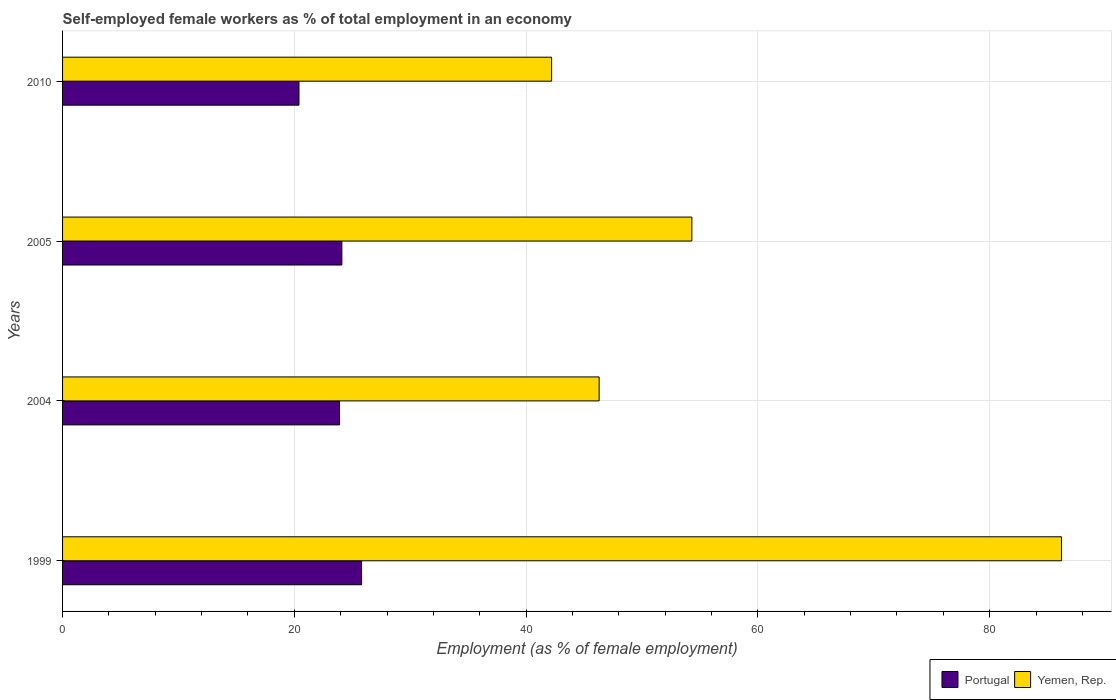How many different coloured bars are there?
Offer a terse response. 2. How many bars are there on the 4th tick from the top?
Your answer should be compact. 2. How many bars are there on the 4th tick from the bottom?
Provide a short and direct response. 2. What is the label of the 3rd group of bars from the top?
Ensure brevity in your answer.  2004. What is the percentage of self-employed female workers in Yemen, Rep. in 1999?
Provide a short and direct response. 86.2. Across all years, what is the maximum percentage of self-employed female workers in Portugal?
Your response must be concise. 25.8. Across all years, what is the minimum percentage of self-employed female workers in Yemen, Rep.?
Offer a terse response. 42.2. In which year was the percentage of self-employed female workers in Yemen, Rep. minimum?
Provide a succinct answer. 2010. What is the total percentage of self-employed female workers in Yemen, Rep. in the graph?
Offer a very short reply. 229. What is the difference between the percentage of self-employed female workers in Yemen, Rep. in 1999 and that in 2005?
Provide a short and direct response. 31.9. What is the difference between the percentage of self-employed female workers in Yemen, Rep. in 2010 and the percentage of self-employed female workers in Portugal in 2005?
Provide a succinct answer. 18.1. What is the average percentage of self-employed female workers in Portugal per year?
Your response must be concise. 23.55. In the year 1999, what is the difference between the percentage of self-employed female workers in Yemen, Rep. and percentage of self-employed female workers in Portugal?
Offer a very short reply. 60.4. What is the ratio of the percentage of self-employed female workers in Yemen, Rep. in 1999 to that in 2004?
Provide a succinct answer. 1.86. What is the difference between the highest and the second highest percentage of self-employed female workers in Portugal?
Ensure brevity in your answer.  1.7. What is the difference between the highest and the lowest percentage of self-employed female workers in Yemen, Rep.?
Make the answer very short. 44. In how many years, is the percentage of self-employed female workers in Portugal greater than the average percentage of self-employed female workers in Portugal taken over all years?
Provide a succinct answer. 3. What does the 2nd bar from the bottom in 2005 represents?
Offer a very short reply. Yemen, Rep. Are the values on the major ticks of X-axis written in scientific E-notation?
Provide a short and direct response. No. What is the title of the graph?
Give a very brief answer. Self-employed female workers as % of total employment in an economy. What is the label or title of the X-axis?
Your response must be concise. Employment (as % of female employment). What is the Employment (as % of female employment) in Portugal in 1999?
Keep it short and to the point. 25.8. What is the Employment (as % of female employment) in Yemen, Rep. in 1999?
Offer a very short reply. 86.2. What is the Employment (as % of female employment) in Portugal in 2004?
Your answer should be very brief. 23.9. What is the Employment (as % of female employment) of Yemen, Rep. in 2004?
Your answer should be very brief. 46.3. What is the Employment (as % of female employment) of Portugal in 2005?
Ensure brevity in your answer.  24.1. What is the Employment (as % of female employment) of Yemen, Rep. in 2005?
Keep it short and to the point. 54.3. What is the Employment (as % of female employment) in Portugal in 2010?
Provide a succinct answer. 20.4. What is the Employment (as % of female employment) in Yemen, Rep. in 2010?
Offer a very short reply. 42.2. Across all years, what is the maximum Employment (as % of female employment) of Portugal?
Make the answer very short. 25.8. Across all years, what is the maximum Employment (as % of female employment) of Yemen, Rep.?
Your answer should be compact. 86.2. Across all years, what is the minimum Employment (as % of female employment) in Portugal?
Provide a succinct answer. 20.4. Across all years, what is the minimum Employment (as % of female employment) of Yemen, Rep.?
Ensure brevity in your answer.  42.2. What is the total Employment (as % of female employment) in Portugal in the graph?
Give a very brief answer. 94.2. What is the total Employment (as % of female employment) in Yemen, Rep. in the graph?
Ensure brevity in your answer.  229. What is the difference between the Employment (as % of female employment) of Portugal in 1999 and that in 2004?
Keep it short and to the point. 1.9. What is the difference between the Employment (as % of female employment) of Yemen, Rep. in 1999 and that in 2004?
Keep it short and to the point. 39.9. What is the difference between the Employment (as % of female employment) in Portugal in 1999 and that in 2005?
Keep it short and to the point. 1.7. What is the difference between the Employment (as % of female employment) of Yemen, Rep. in 1999 and that in 2005?
Ensure brevity in your answer.  31.9. What is the difference between the Employment (as % of female employment) in Portugal in 2004 and that in 2005?
Give a very brief answer. -0.2. What is the difference between the Employment (as % of female employment) of Yemen, Rep. in 2004 and that in 2005?
Ensure brevity in your answer.  -8. What is the difference between the Employment (as % of female employment) in Portugal in 2004 and that in 2010?
Offer a very short reply. 3.5. What is the difference between the Employment (as % of female employment) of Portugal in 2005 and that in 2010?
Ensure brevity in your answer.  3.7. What is the difference between the Employment (as % of female employment) in Yemen, Rep. in 2005 and that in 2010?
Your answer should be very brief. 12.1. What is the difference between the Employment (as % of female employment) of Portugal in 1999 and the Employment (as % of female employment) of Yemen, Rep. in 2004?
Offer a terse response. -20.5. What is the difference between the Employment (as % of female employment) in Portugal in 1999 and the Employment (as % of female employment) in Yemen, Rep. in 2005?
Your answer should be compact. -28.5. What is the difference between the Employment (as % of female employment) of Portugal in 1999 and the Employment (as % of female employment) of Yemen, Rep. in 2010?
Your answer should be very brief. -16.4. What is the difference between the Employment (as % of female employment) of Portugal in 2004 and the Employment (as % of female employment) of Yemen, Rep. in 2005?
Offer a terse response. -30.4. What is the difference between the Employment (as % of female employment) of Portugal in 2004 and the Employment (as % of female employment) of Yemen, Rep. in 2010?
Your response must be concise. -18.3. What is the difference between the Employment (as % of female employment) in Portugal in 2005 and the Employment (as % of female employment) in Yemen, Rep. in 2010?
Provide a short and direct response. -18.1. What is the average Employment (as % of female employment) of Portugal per year?
Make the answer very short. 23.55. What is the average Employment (as % of female employment) in Yemen, Rep. per year?
Ensure brevity in your answer.  57.25. In the year 1999, what is the difference between the Employment (as % of female employment) in Portugal and Employment (as % of female employment) in Yemen, Rep.?
Give a very brief answer. -60.4. In the year 2004, what is the difference between the Employment (as % of female employment) of Portugal and Employment (as % of female employment) of Yemen, Rep.?
Provide a short and direct response. -22.4. In the year 2005, what is the difference between the Employment (as % of female employment) in Portugal and Employment (as % of female employment) in Yemen, Rep.?
Keep it short and to the point. -30.2. In the year 2010, what is the difference between the Employment (as % of female employment) in Portugal and Employment (as % of female employment) in Yemen, Rep.?
Give a very brief answer. -21.8. What is the ratio of the Employment (as % of female employment) of Portugal in 1999 to that in 2004?
Give a very brief answer. 1.08. What is the ratio of the Employment (as % of female employment) of Yemen, Rep. in 1999 to that in 2004?
Offer a very short reply. 1.86. What is the ratio of the Employment (as % of female employment) of Portugal in 1999 to that in 2005?
Make the answer very short. 1.07. What is the ratio of the Employment (as % of female employment) of Yemen, Rep. in 1999 to that in 2005?
Provide a succinct answer. 1.59. What is the ratio of the Employment (as % of female employment) in Portugal in 1999 to that in 2010?
Give a very brief answer. 1.26. What is the ratio of the Employment (as % of female employment) in Yemen, Rep. in 1999 to that in 2010?
Provide a succinct answer. 2.04. What is the ratio of the Employment (as % of female employment) of Portugal in 2004 to that in 2005?
Offer a very short reply. 0.99. What is the ratio of the Employment (as % of female employment) of Yemen, Rep. in 2004 to that in 2005?
Keep it short and to the point. 0.85. What is the ratio of the Employment (as % of female employment) in Portugal in 2004 to that in 2010?
Your response must be concise. 1.17. What is the ratio of the Employment (as % of female employment) in Yemen, Rep. in 2004 to that in 2010?
Give a very brief answer. 1.1. What is the ratio of the Employment (as % of female employment) of Portugal in 2005 to that in 2010?
Offer a terse response. 1.18. What is the ratio of the Employment (as % of female employment) of Yemen, Rep. in 2005 to that in 2010?
Your response must be concise. 1.29. What is the difference between the highest and the second highest Employment (as % of female employment) in Portugal?
Your answer should be compact. 1.7. What is the difference between the highest and the second highest Employment (as % of female employment) of Yemen, Rep.?
Provide a short and direct response. 31.9. 